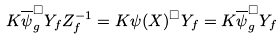Convert formula to latex. <formula><loc_0><loc_0><loc_500><loc_500>K \overline { \psi } _ { g } ^ { \square } Y _ { f } Z _ { f } ^ { - 1 } = K \psi ( X ) ^ { \square } Y _ { f } = K \overline { \psi } _ { g } ^ { \square } Y _ { f }</formula> 